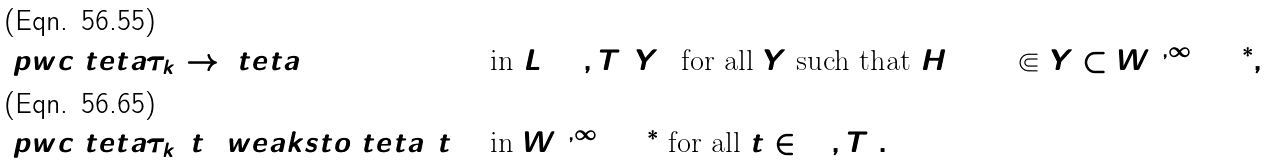<formula> <loc_0><loc_0><loc_500><loc_500>& \ p w c \ t e t a { \tau _ { k } } \to \ t e t a & & \text { in } L ^ { 2 } ( 0 , T ; Y ) \text { for all $Y$ such that $H^{1}(\Omega) \Subset Y \subset W^{1,\infty} (\Omega)^{*}$} , \\ & \ p w c \ t e t a { \tau _ { k } } ( t ) \ w e a k s t o \ t e t a ( t ) & & \text { in } W ^ { 1 , \infty } ( \Omega ) ^ { * } \text { for all } t \in [ 0 , T ] .</formula> 